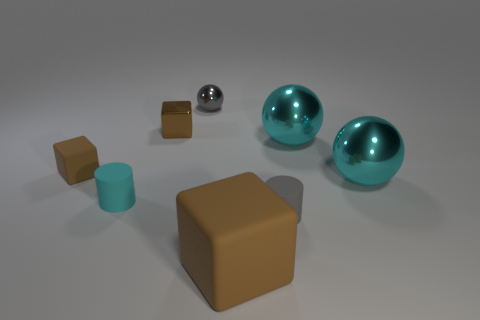Subtract all brown cubes. How many were subtracted if there are1brown cubes left? 2 Add 2 blue things. How many objects exist? 10 Subtract all blocks. How many objects are left? 5 Add 2 tiny brown matte spheres. How many tiny brown matte spheres exist? 2 Subtract 0 red balls. How many objects are left? 8 Subtract all big green balls. Subtract all tiny cylinders. How many objects are left? 6 Add 7 tiny cyan cylinders. How many tiny cyan cylinders are left? 8 